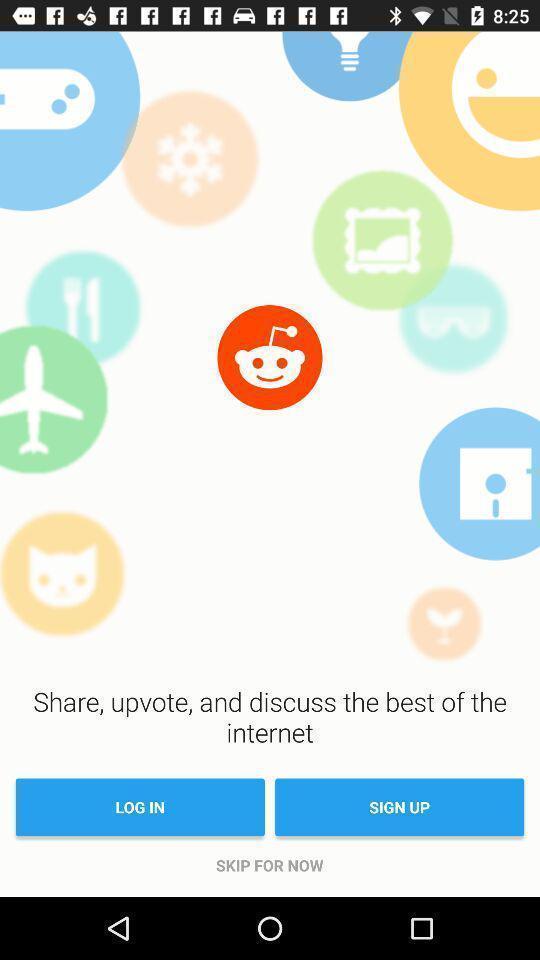Give me a summary of this screen capture. Sign up/log in page for an application. 